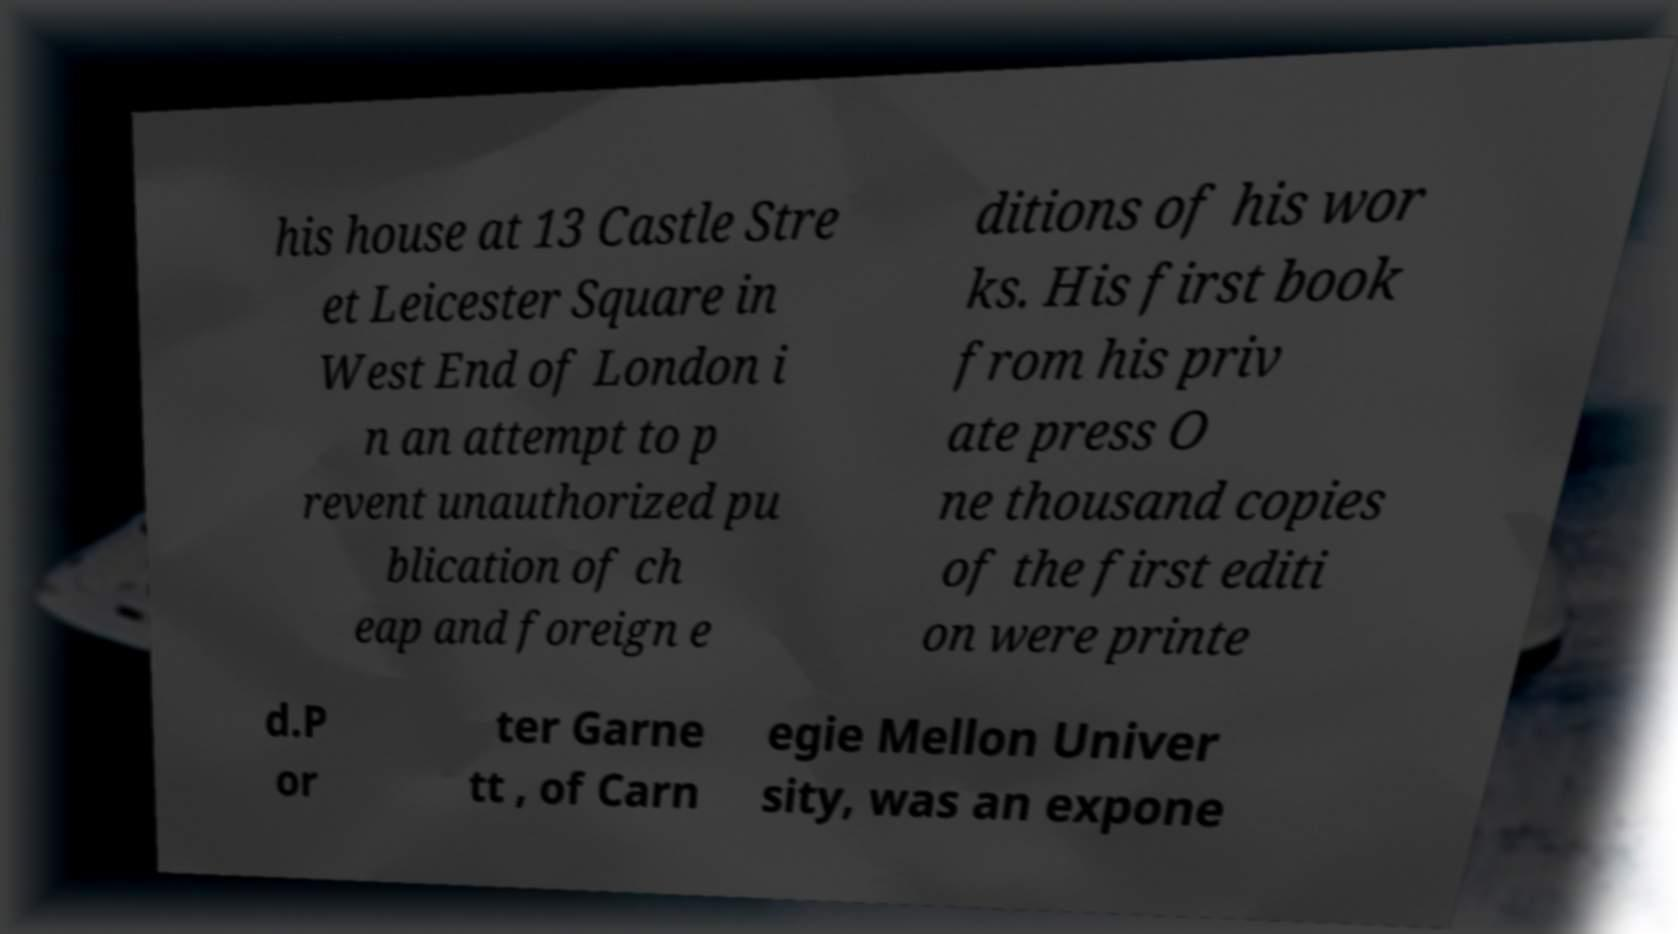What messages or text are displayed in this image? I need them in a readable, typed format. his house at 13 Castle Stre et Leicester Square in West End of London i n an attempt to p revent unauthorized pu blication of ch eap and foreign e ditions of his wor ks. His first book from his priv ate press O ne thousand copies of the first editi on were printe d.P or ter Garne tt , of Carn egie Mellon Univer sity, was an expone 